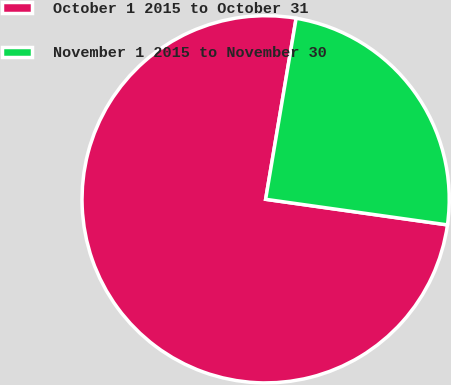Convert chart to OTSL. <chart><loc_0><loc_0><loc_500><loc_500><pie_chart><fcel>October 1 2015 to October 31<fcel>November 1 2015 to November 30<nl><fcel>75.43%<fcel>24.57%<nl></chart> 